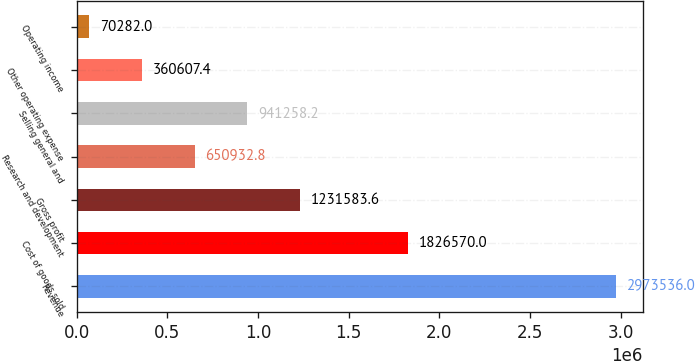Convert chart. <chart><loc_0><loc_0><loc_500><loc_500><bar_chart><fcel>Revenue<fcel>Cost of goods sold<fcel>Gross profit<fcel>Research and development<fcel>Selling general and<fcel>Other operating expense<fcel>Operating income<nl><fcel>2.97354e+06<fcel>1.82657e+06<fcel>1.23158e+06<fcel>650933<fcel>941258<fcel>360607<fcel>70282<nl></chart> 